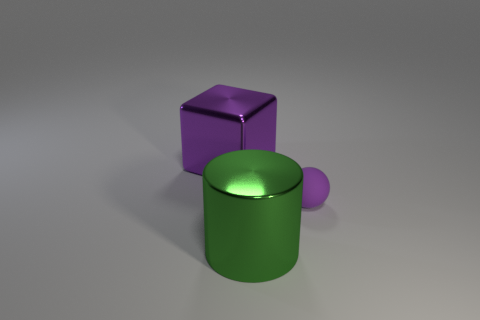How could these shapes be utilized in a learning environment? These shapes are excellent resources for educational purposes. They could be used in a classroom to teach young students about geometry, to help them understand different properties such as vertices, edges, and faces, and to introduce basic 3D modeling concepts to older students who are learning about computer graphics or engineering design principles. 